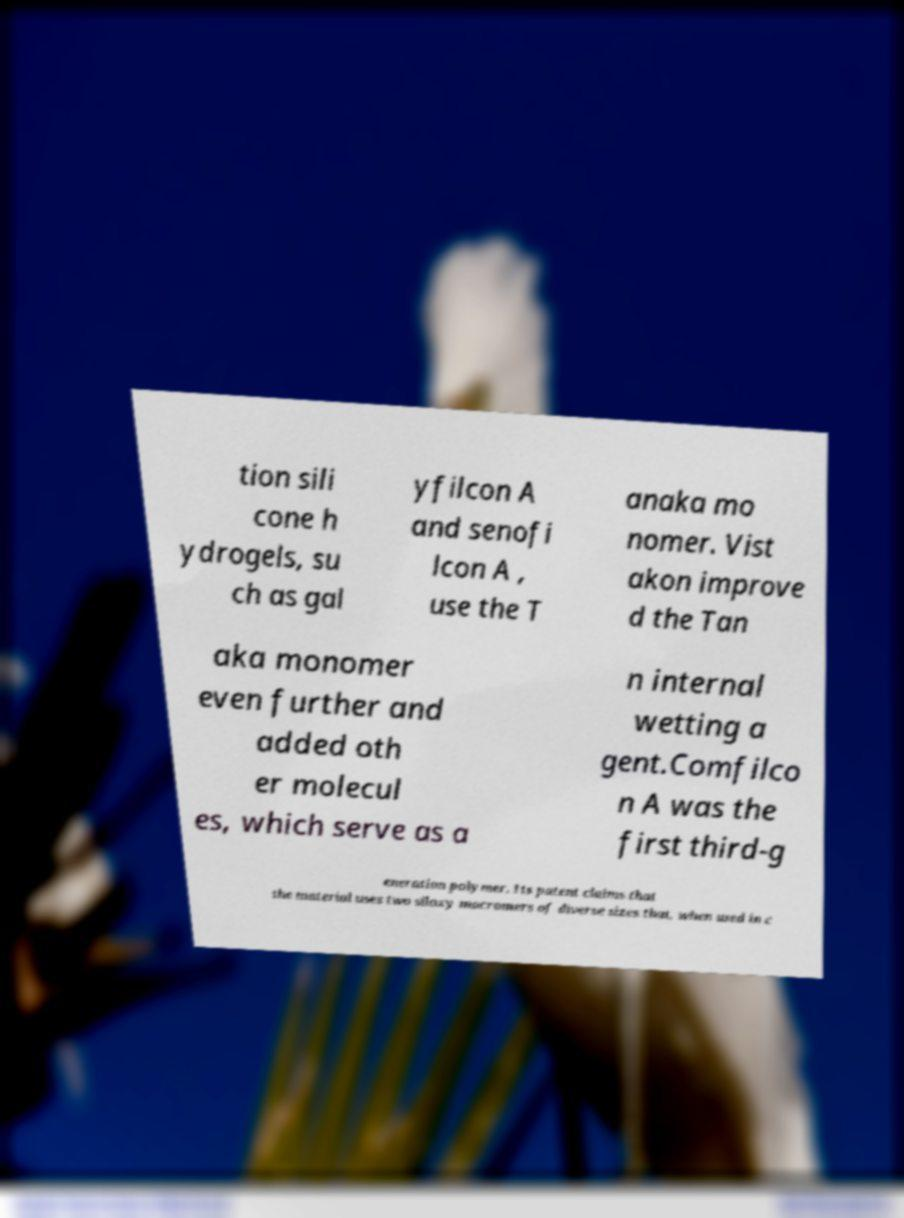Can you accurately transcribe the text from the provided image for me? tion sili cone h ydrogels, su ch as gal yfilcon A and senofi lcon A , use the T anaka mo nomer. Vist akon improve d the Tan aka monomer even further and added oth er molecul es, which serve as a n internal wetting a gent.Comfilco n A was the first third-g eneration polymer. Its patent claims that the material uses two siloxy macromers of diverse sizes that, when used in c 